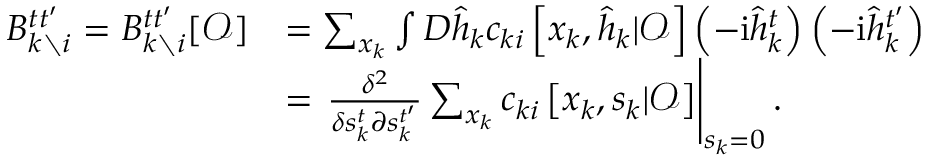Convert formula to latex. <formula><loc_0><loc_0><loc_500><loc_500>\begin{array} { r l } { B _ { k \ i } ^ { t t ^ { \prime } } = B _ { k \ i } ^ { t t ^ { \prime } } [ \mathcal { O } ] } & { = \sum _ { x _ { k } } \int D \hat { h } _ { k } c _ { k i } \left [ x _ { k } , \hat { h } _ { k } | \mathcal { O } \right ] \left ( - i \hat { h } _ { k } ^ { t } \right ) \left ( - i \hat { h } _ { k } ^ { t ^ { \prime } } \right ) } \\ & { = \frac { \delta ^ { 2 } } { \delta s _ { k } ^ { t } \partial s _ { k } ^ { t ^ { \prime } } } \sum _ { x _ { k } } c _ { k i } \left [ x _ { k } , s _ { k } | \mathcal { O } \right ] \right | _ { s _ { k } = 0 } . } \end{array}</formula> 